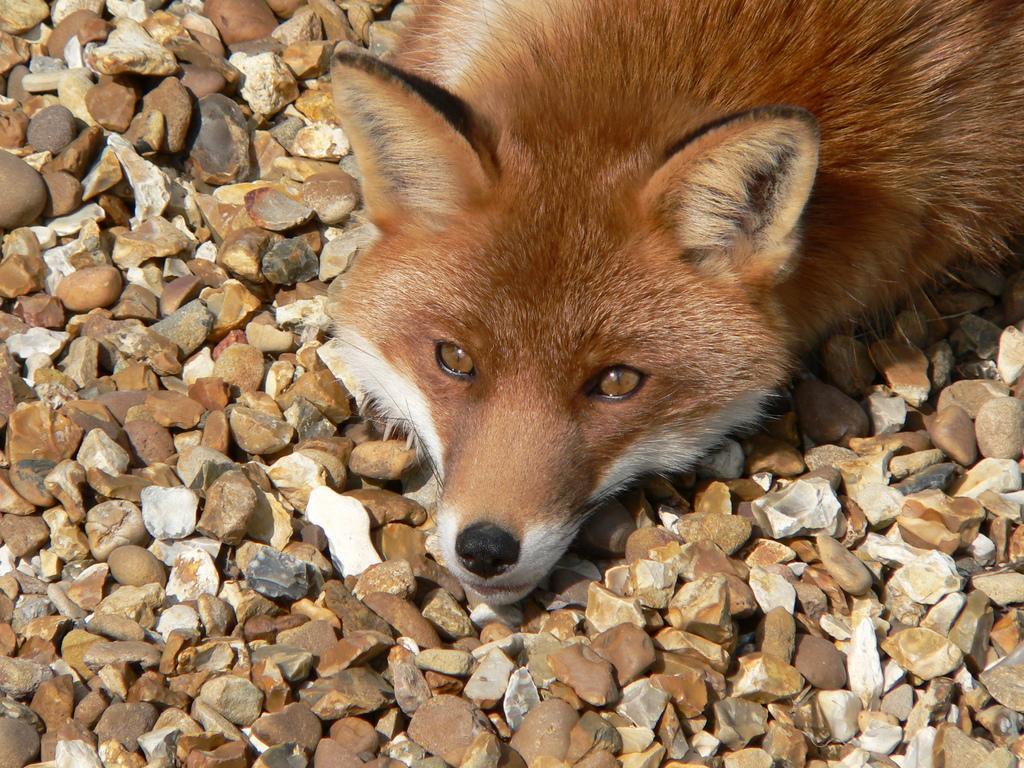What animal is in the picture? There is a fox in the picture. What colors can be seen on the fox? The fox is white and brown in color. What type of terrain is visible in the picture? There are small stones on the ground in the picture. Where is the donkey sitting on its throne in the picture? There is no donkey or throne present in the image; it features a fox in a setting with small stones on the ground. 